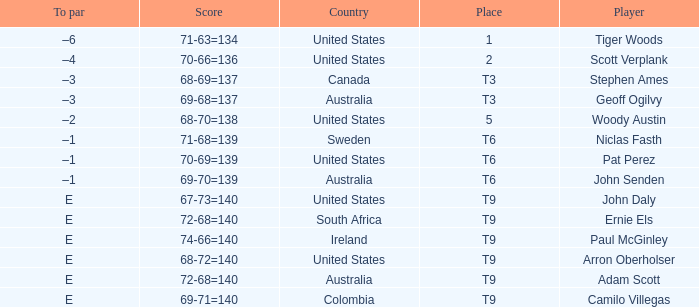Which player is from Sweden? Niclas Fasth. Can you give me this table as a dict? {'header': ['To par', 'Score', 'Country', 'Place', 'Player'], 'rows': [['–6', '71-63=134', 'United States', '1', 'Tiger Woods'], ['–4', '70-66=136', 'United States', '2', 'Scott Verplank'], ['–3', '68-69=137', 'Canada', 'T3', 'Stephen Ames'], ['–3', '69-68=137', 'Australia', 'T3', 'Geoff Ogilvy'], ['–2', '68-70=138', 'United States', '5', 'Woody Austin'], ['–1', '71-68=139', 'Sweden', 'T6', 'Niclas Fasth'], ['–1', '70-69=139', 'United States', 'T6', 'Pat Perez'], ['–1', '69-70=139', 'Australia', 'T6', 'John Senden'], ['E', '67-73=140', 'United States', 'T9', 'John Daly'], ['E', '72-68=140', 'South Africa', 'T9', 'Ernie Els'], ['E', '74-66=140', 'Ireland', 'T9', 'Paul McGinley'], ['E', '68-72=140', 'United States', 'T9', 'Arron Oberholser'], ['E', '72-68=140', 'Australia', 'T9', 'Adam Scott'], ['E', '69-71=140', 'Colombia', 'T9', 'Camilo Villegas']]} 